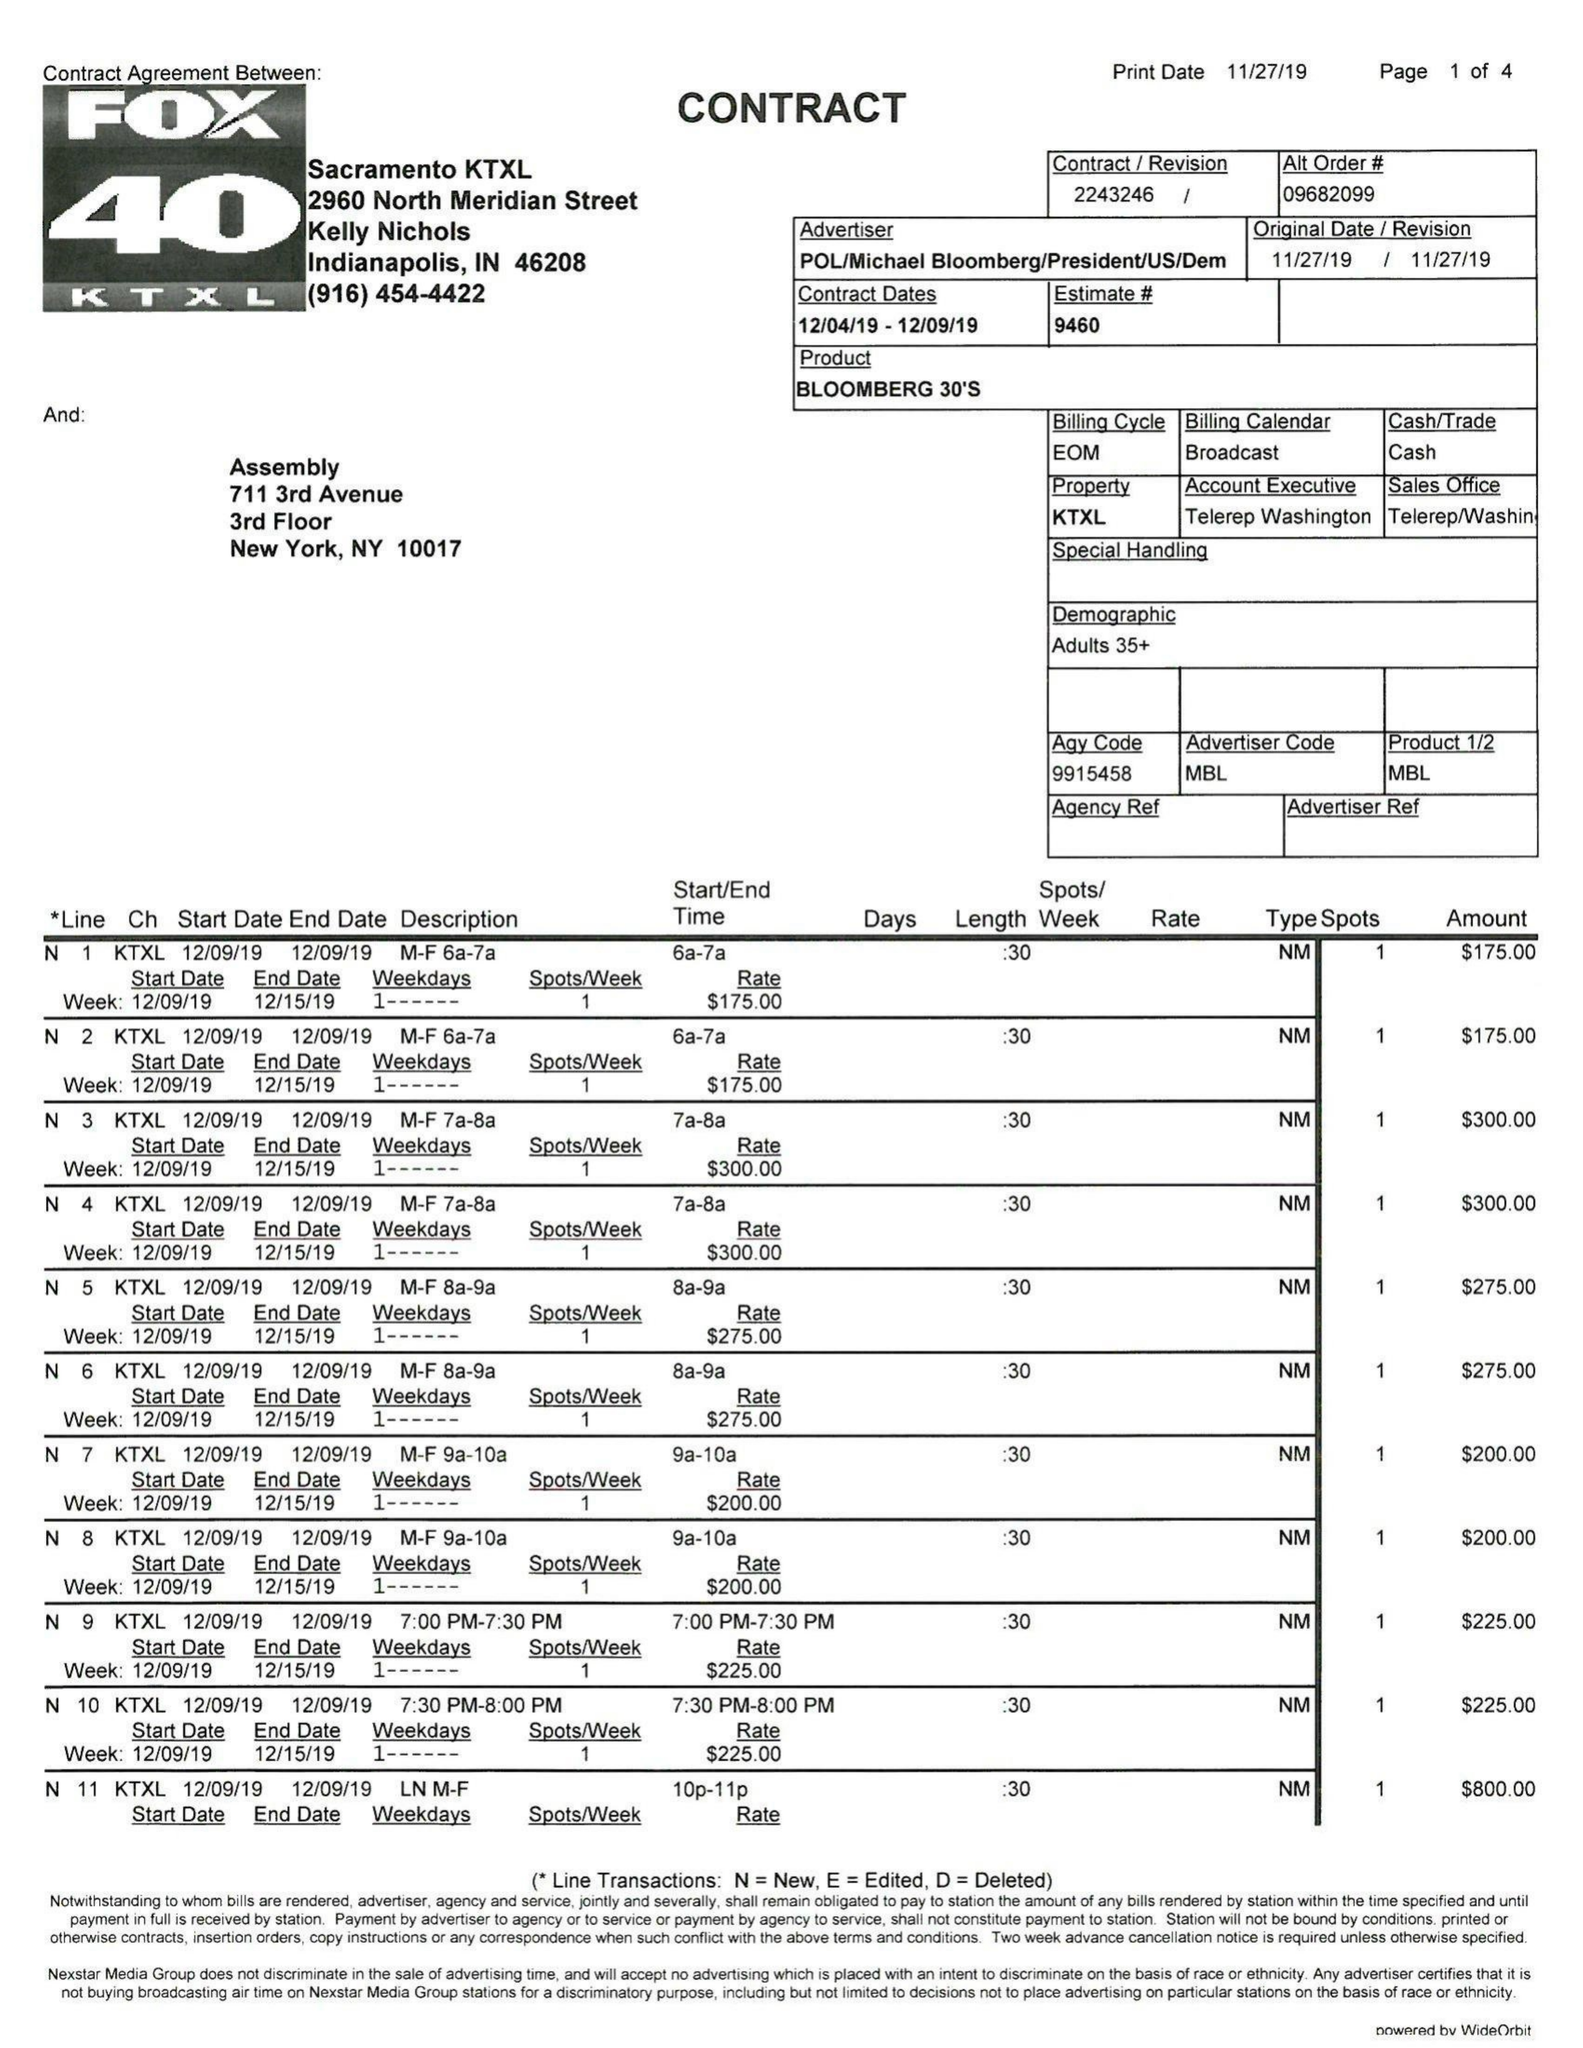What is the value for the flight_from?
Answer the question using a single word or phrase. 12/04/19 